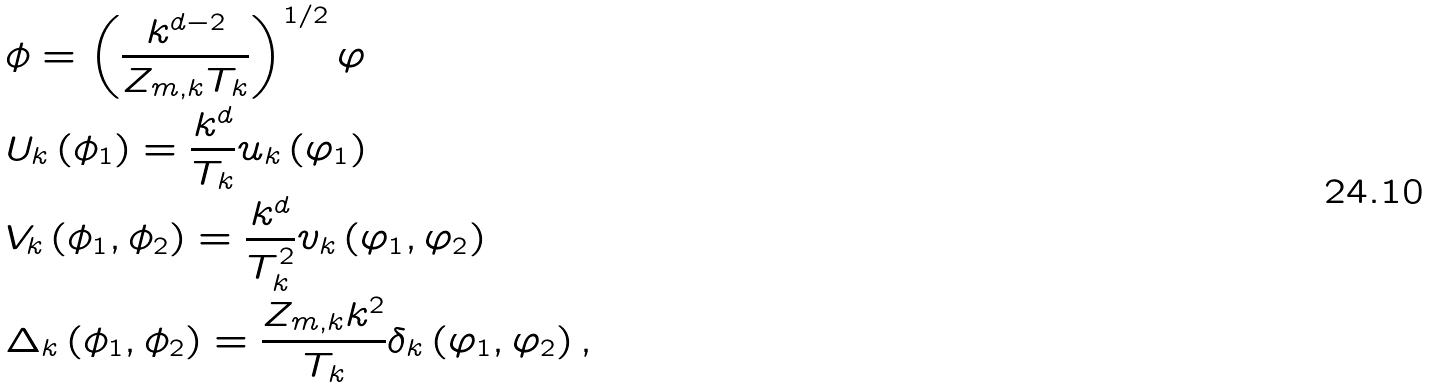<formula> <loc_0><loc_0><loc_500><loc_500>& \phi = \left ( \frac { k ^ { d - 2 } } { Z _ { m , k } T _ { k } } \right ) ^ { 1 / 2 } \varphi \\ & U _ { k } \left ( \phi _ { 1 } \right ) = \frac { k ^ { d } } { T _ { k } } u _ { k } \left ( \varphi _ { 1 } \right ) \\ & V _ { k } \left ( \phi _ { 1 } , \phi _ { 2 } \right ) = \frac { k ^ { d } } { T _ { k } ^ { 2 } } v _ { k } \left ( \varphi _ { 1 } , \varphi _ { 2 } \right ) \\ & \Delta _ { k } \left ( \phi _ { 1 } , \phi _ { 2 } \right ) = \frac { Z _ { m , k } k ^ { 2 } } { T _ { k } } \delta _ { k } \left ( \varphi _ { 1 } , \varphi _ { 2 } \right ) ,</formula> 